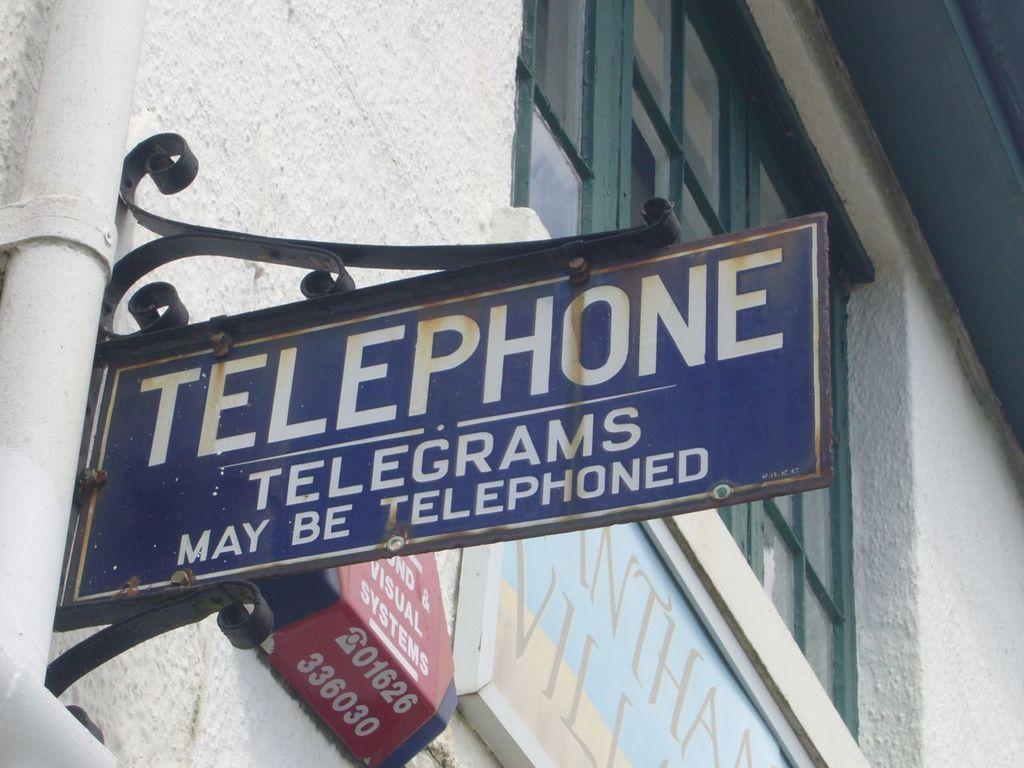Describe this image in one or two sentences. In this image in the center there are some boards, on the boards there is text. And in the background there is a building, and on the left side of the image there is a pipe. And in the center there is a window. 